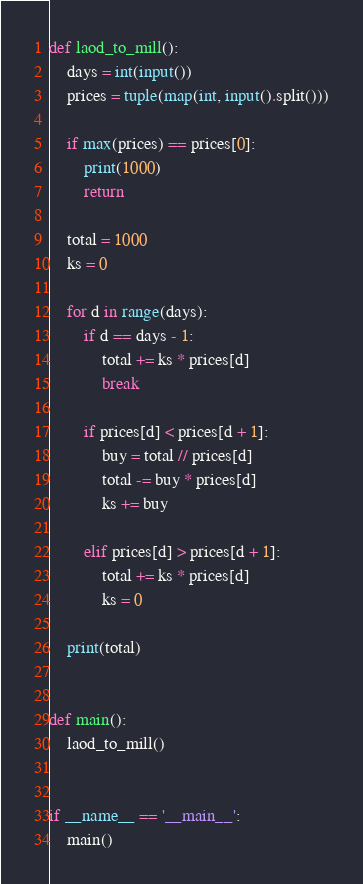<code> <loc_0><loc_0><loc_500><loc_500><_Python_>def laod_to_mill():
    days = int(input())
    prices = tuple(map(int, input().split()))

    if max(prices) == prices[0]:
        print(1000)
        return

    total = 1000
    ks = 0

    for d in range(days):
        if d == days - 1:
            total += ks * prices[d]
            break

        if prices[d] < prices[d + 1]:
            buy = total // prices[d]
            total -= buy * prices[d]
            ks += buy

        elif prices[d] > prices[d + 1]:
            total += ks * prices[d]
            ks = 0

    print(total)


def main():
    laod_to_mill()


if __name__ == '__main__':
    main()
</code> 